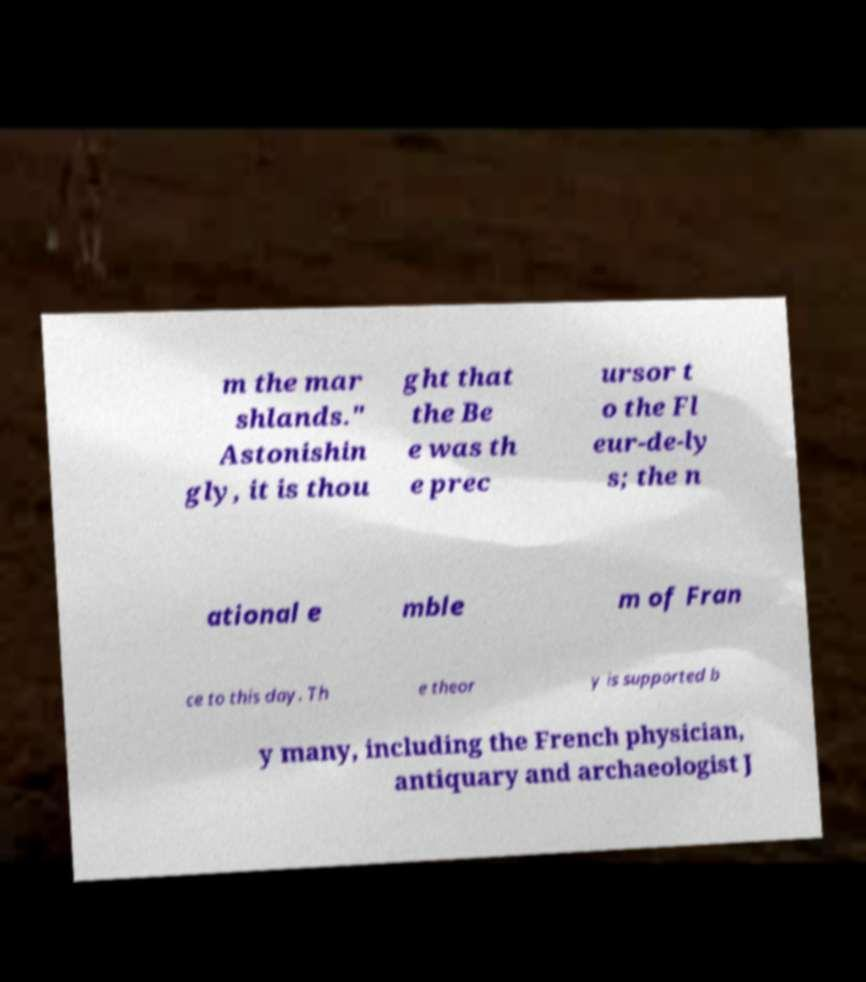There's text embedded in this image that I need extracted. Can you transcribe it verbatim? m the mar shlands." Astonishin gly, it is thou ght that the Be e was th e prec ursor t o the Fl eur-de-ly s; the n ational e mble m of Fran ce to this day. Th e theor y is supported b y many, including the French physician, antiquary and archaeologist J 